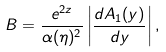<formula> <loc_0><loc_0><loc_500><loc_500>B = \frac { e ^ { 2 z } } { \alpha ( \eta ) ^ { 2 } } \left | \frac { d A _ { 1 } ( y ) } { d y } \right | ,</formula> 